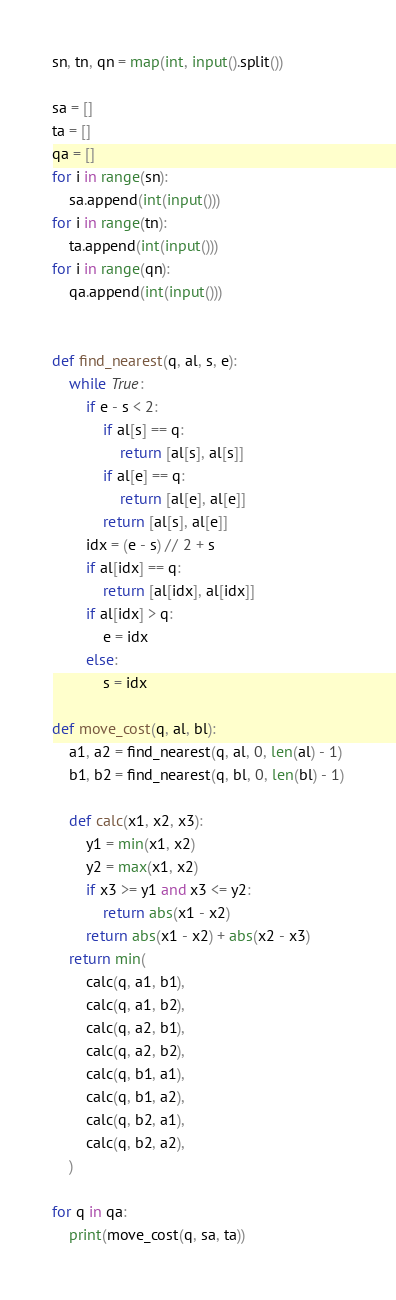Convert code to text. <code><loc_0><loc_0><loc_500><loc_500><_Python_>sn, tn, qn = map(int, input().split())

sa = []
ta = []
qa = []
for i in range(sn):
    sa.append(int(input()))
for i in range(tn):
    ta.append(int(input()))
for i in range(qn):
    qa.append(int(input()))


def find_nearest(q, al, s, e):
    while True:
        if e - s < 2:
            if al[s] == q:
                return [al[s], al[s]]
            if al[e] == q:
                return [al[e], al[e]]
            return [al[s], al[e]]
        idx = (e - s) // 2 + s
        if al[idx] == q:
            return [al[idx], al[idx]]
        if al[idx] > q:
            e = idx
        else:
            s = idx

def move_cost(q, al, bl):
    a1, a2 = find_nearest(q, al, 0, len(al) - 1)
    b1, b2 = find_nearest(q, bl, 0, len(bl) - 1)

    def calc(x1, x2, x3):
        y1 = min(x1, x2)
        y2 = max(x1, x2)
        if x3 >= y1 and x3 <= y2:
            return abs(x1 - x2)
        return abs(x1 - x2) + abs(x2 - x3)
    return min(
        calc(q, a1, b1),
        calc(q, a1, b2),
        calc(q, a2, b1),
        calc(q, a2, b2),
        calc(q, b1, a1),
        calc(q, b1, a2),
        calc(q, b2, a1),
        calc(q, b2, a2),
    )

for q in qa:
    print(move_cost(q, sa, ta))
</code> 